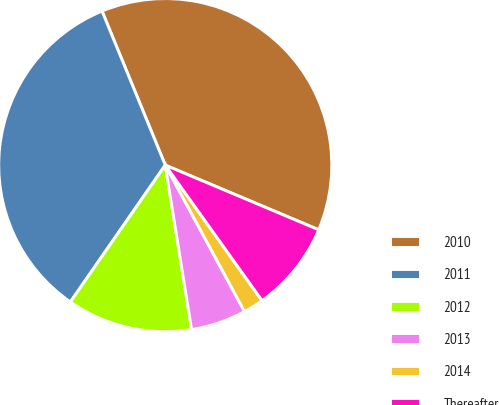Convert chart to OTSL. <chart><loc_0><loc_0><loc_500><loc_500><pie_chart><fcel>2010<fcel>2011<fcel>2012<fcel>2013<fcel>2014<fcel>Thereafter<nl><fcel>37.55%<fcel>34.15%<fcel>12.18%<fcel>5.37%<fcel>1.97%<fcel>8.78%<nl></chart> 